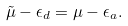<formula> <loc_0><loc_0><loc_500><loc_500>\tilde { \mu } - \epsilon _ { d } = \mu - \epsilon _ { a } .</formula> 